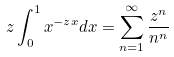Convert formula to latex. <formula><loc_0><loc_0><loc_500><loc_500>z \int _ { 0 } ^ { 1 } x ^ { - z x } d x = \sum _ { n = 1 } ^ { \infty } \frac { z ^ { n } } { n ^ { n } }</formula> 